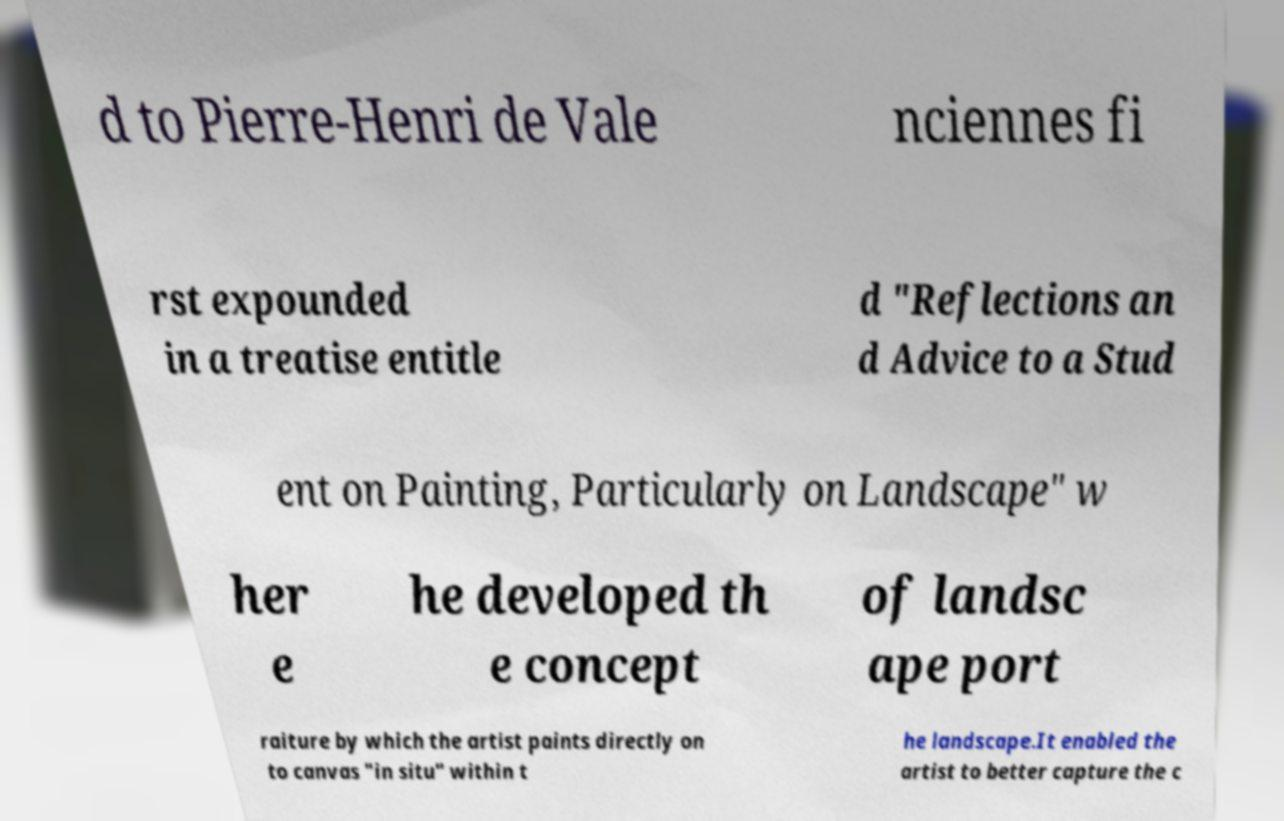Please identify and transcribe the text found in this image. d to Pierre-Henri de Vale nciennes fi rst expounded in a treatise entitle d "Reflections an d Advice to a Stud ent on Painting, Particularly on Landscape" w her e he developed th e concept of landsc ape port raiture by which the artist paints directly on to canvas "in situ" within t he landscape.It enabled the artist to better capture the c 